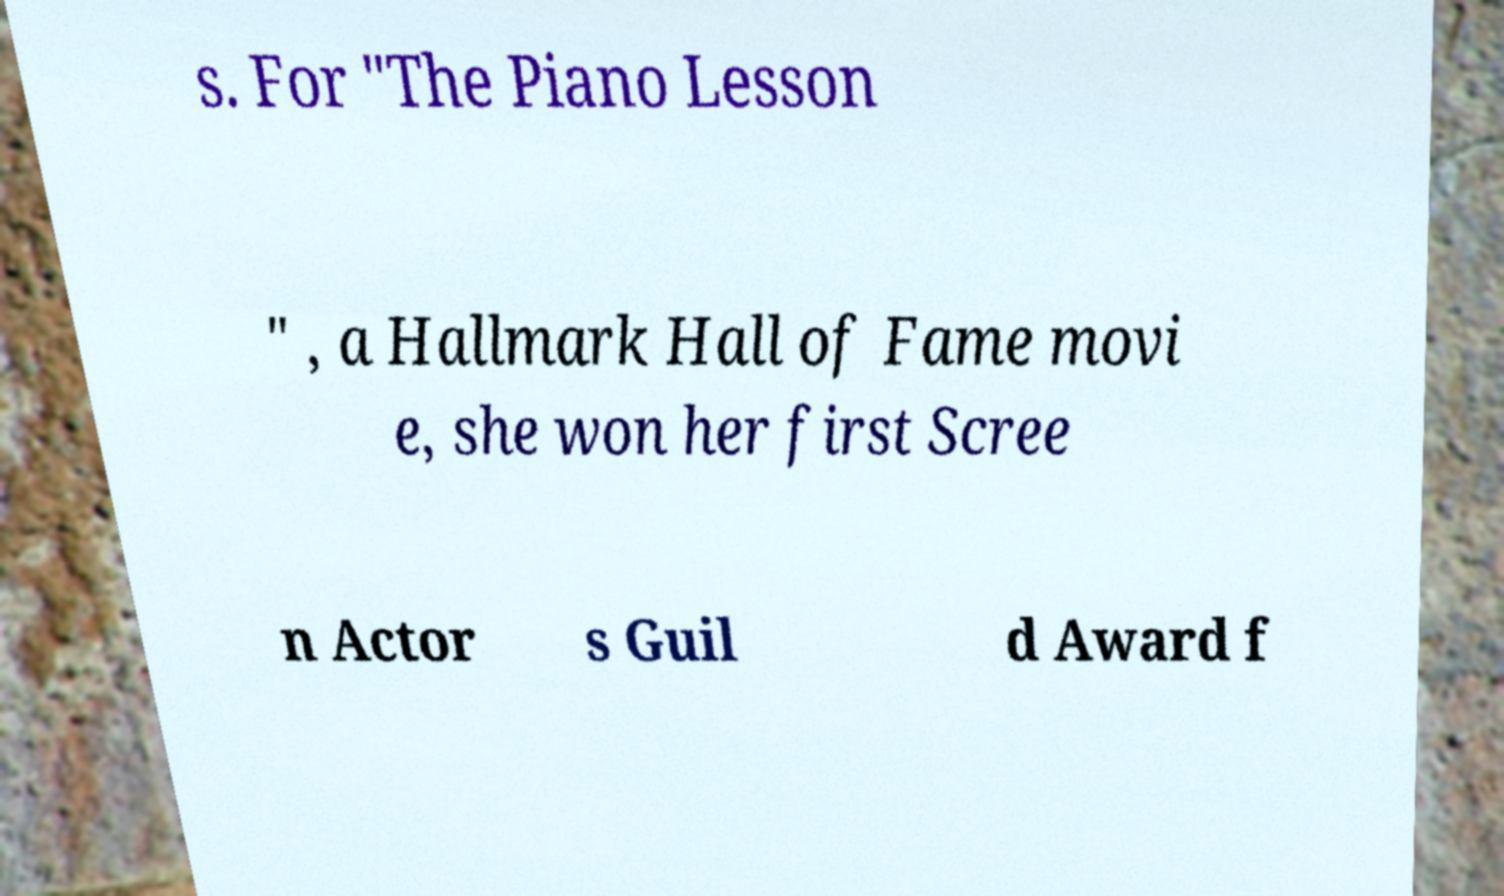What messages or text are displayed in this image? I need them in a readable, typed format. s. For "The Piano Lesson " , a Hallmark Hall of Fame movi e, she won her first Scree n Actor s Guil d Award f 